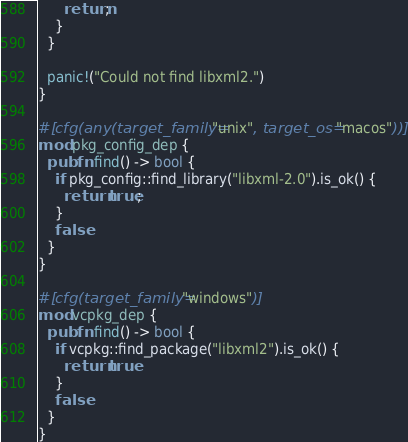<code> <loc_0><loc_0><loc_500><loc_500><_Rust_>      return;
    }
  }

  panic!("Could not find libxml2.")
}

#[cfg(any(target_family="unix", target_os="macos"))]
mod pkg_config_dep {
  pub fn find() -> bool {
    if pkg_config::find_library("libxml-2.0").is_ok() {
      return true;
    }
    false
  }
}

#[cfg(target_family="windows")]
mod vcpkg_dep {
  pub fn find() -> bool {
    if vcpkg::find_package("libxml2").is_ok() {
      return true
    }
    false
  }
}</code> 